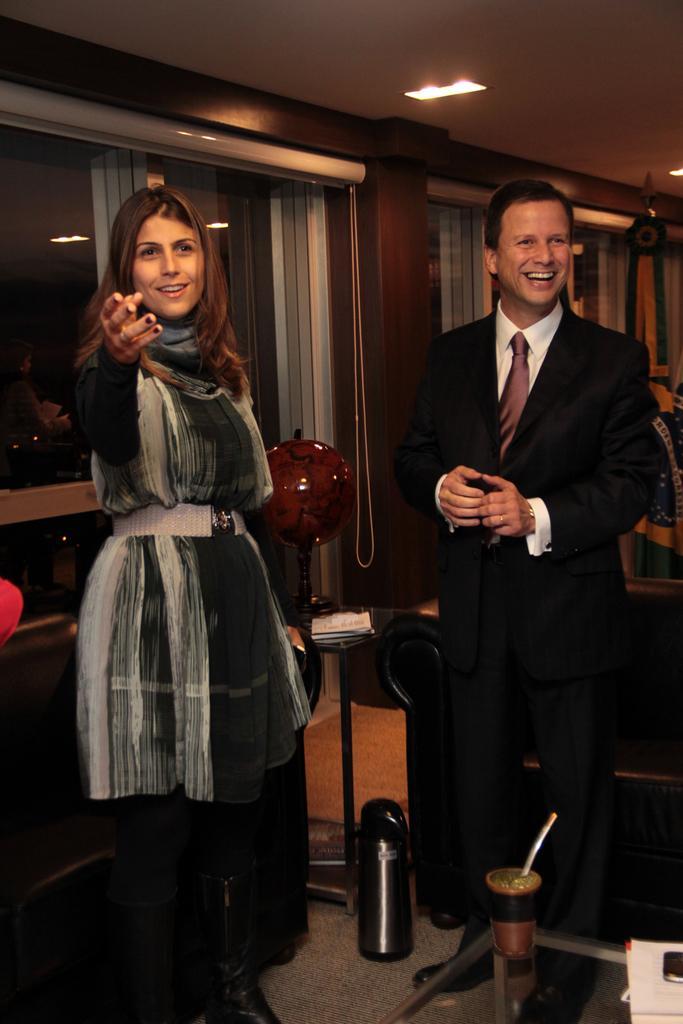Describe this image in one or two sentences. This is an inside view of a room. Here I can see a woman and a man standing on the floor and smiling. In the bottom right there is a small glass table on which a glass and some other objects are placed. At the back of this woman there is a table. At the back of this man there is a couch. In the background there are few curtains to the wall. At the top of the image there is a light to the roof. 